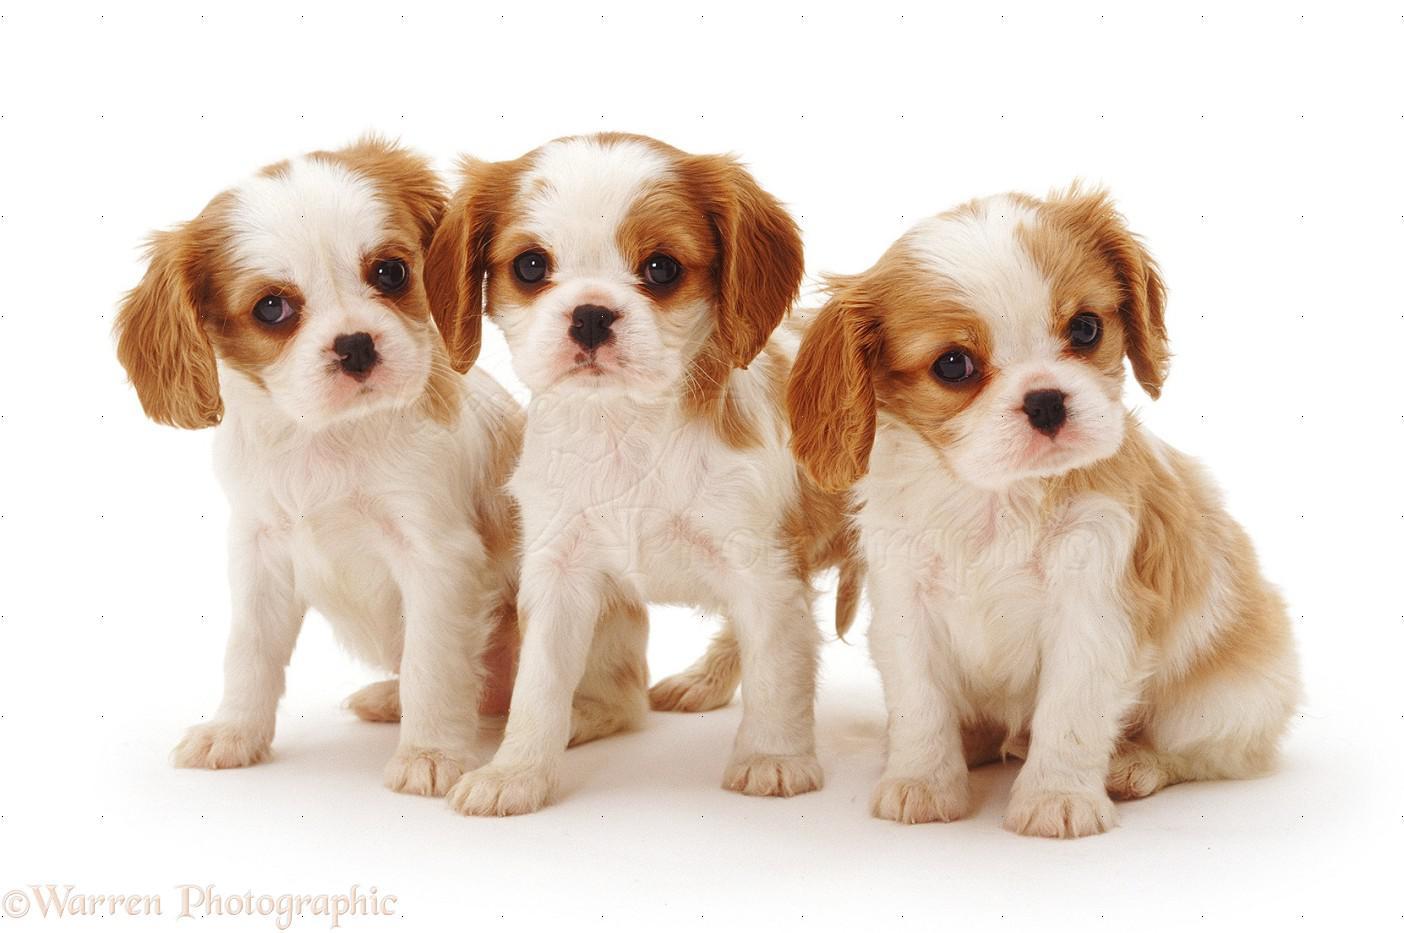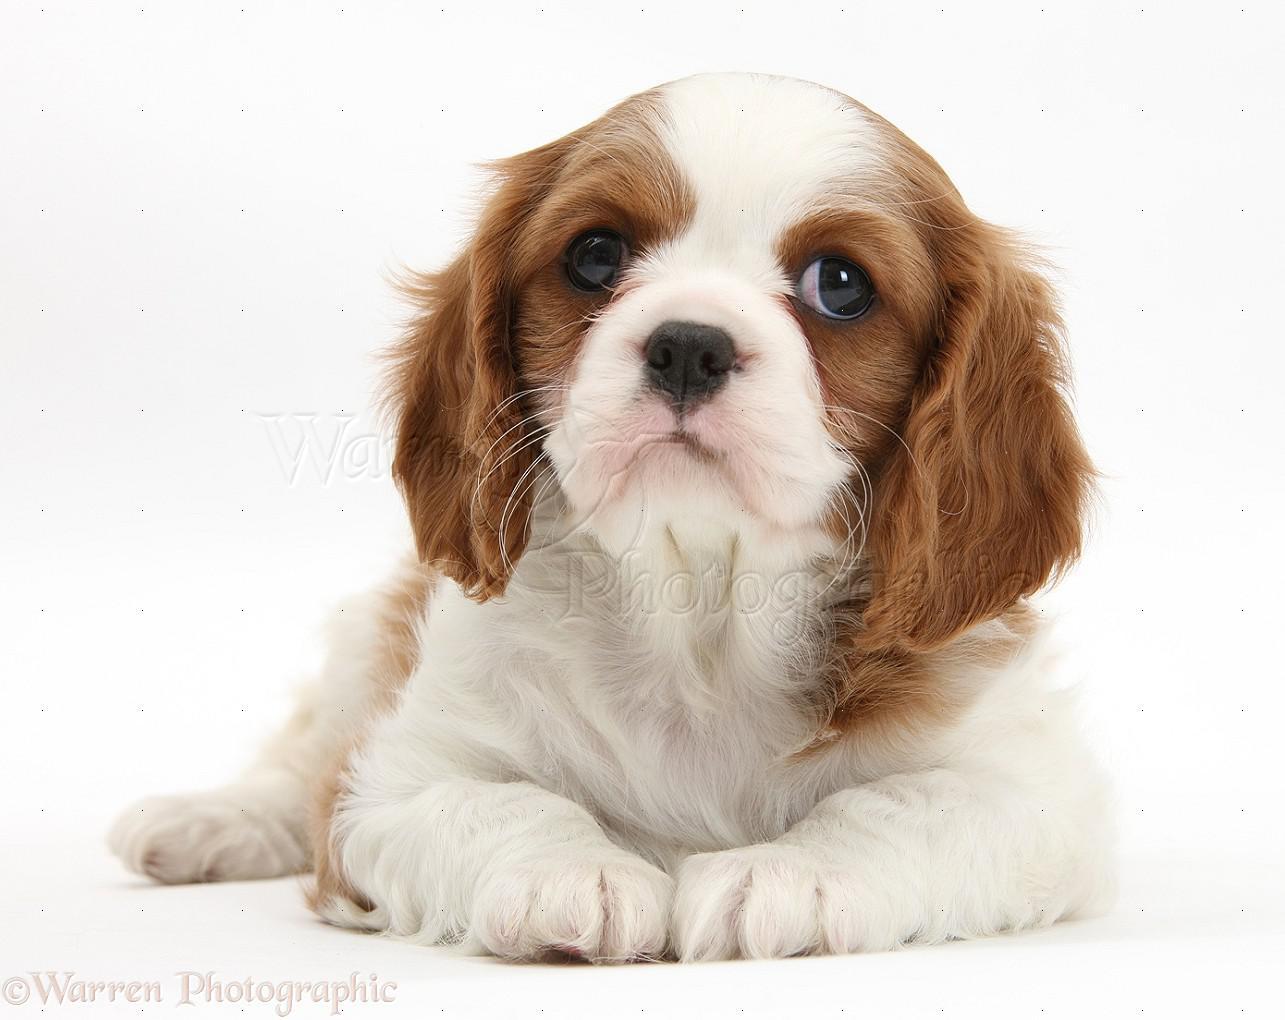The first image is the image on the left, the second image is the image on the right. Examine the images to the left and right. Is the description "There are no more than three animals" accurate? Answer yes or no. No. 